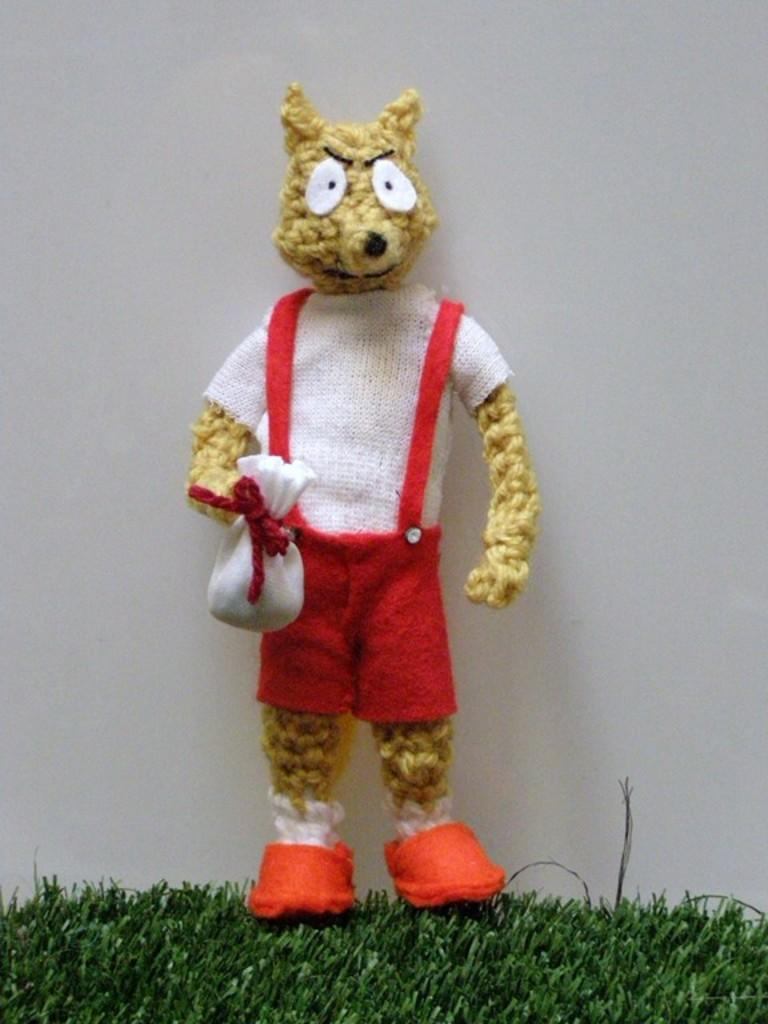What object can be seen in the image? There is a toy in the image. Where is the toy located? The toy is on a grass path. What is the color of the background in the image? The background in the image is white. How does the toy rub against the grass path in the image? The toy does not rub against the grass path in the image; it is stationary on the path. 